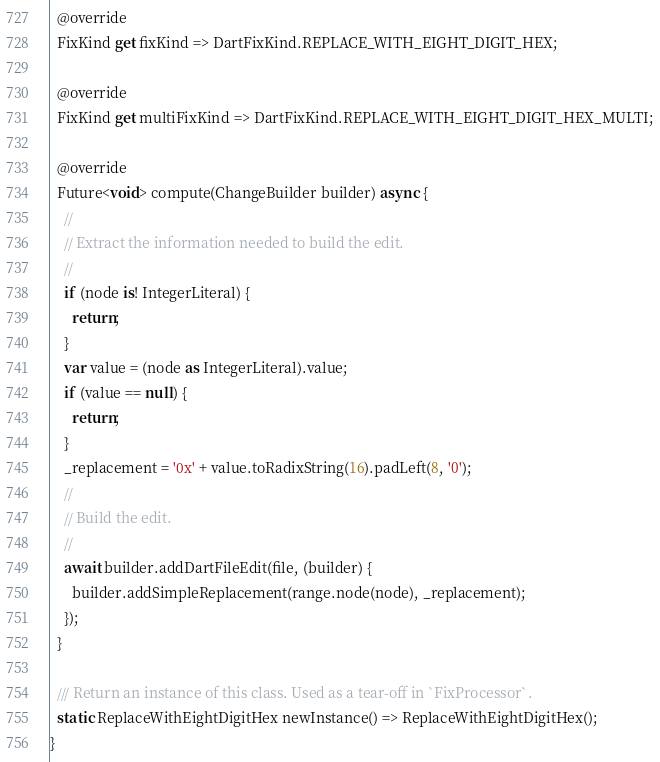<code> <loc_0><loc_0><loc_500><loc_500><_Dart_>  @override
  FixKind get fixKind => DartFixKind.REPLACE_WITH_EIGHT_DIGIT_HEX;

  @override
  FixKind get multiFixKind => DartFixKind.REPLACE_WITH_EIGHT_DIGIT_HEX_MULTI;

  @override
  Future<void> compute(ChangeBuilder builder) async {
    //
    // Extract the information needed to build the edit.
    //
    if (node is! IntegerLiteral) {
      return;
    }
    var value = (node as IntegerLiteral).value;
    if (value == null) {
      return;
    }
    _replacement = '0x' + value.toRadixString(16).padLeft(8, '0');
    //
    // Build the edit.
    //
    await builder.addDartFileEdit(file, (builder) {
      builder.addSimpleReplacement(range.node(node), _replacement);
    });
  }

  /// Return an instance of this class. Used as a tear-off in `FixProcessor`.
  static ReplaceWithEightDigitHex newInstance() => ReplaceWithEightDigitHex();
}
</code> 